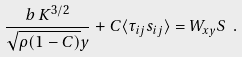Convert formula to latex. <formula><loc_0><loc_0><loc_500><loc_500>\frac { b \, K ^ { 3 / 2 } } { \sqrt { \rho ( 1 - C ) } y } + C \langle \tau _ { i j } s _ { i j } \rangle = W _ { x y } S \ .</formula> 